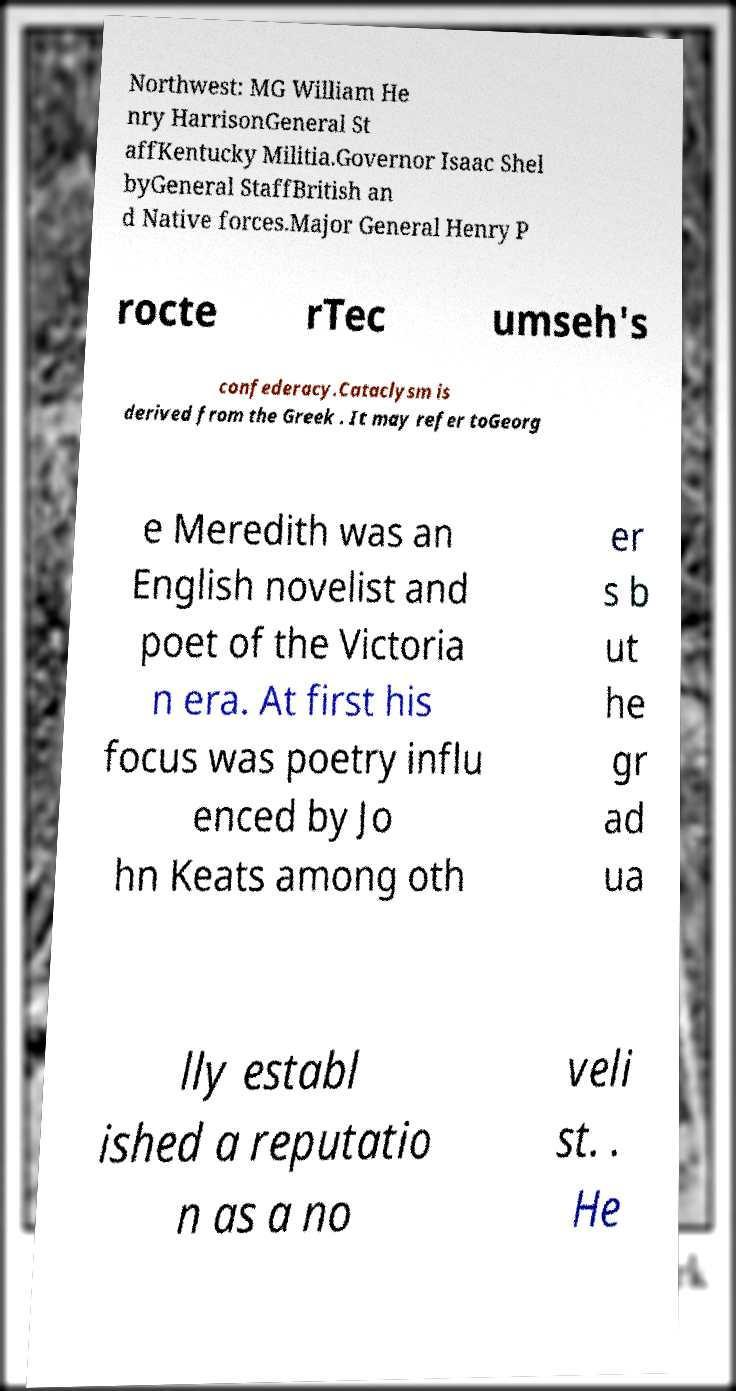Can you read and provide the text displayed in the image?This photo seems to have some interesting text. Can you extract and type it out for me? Northwest: MG William He nry HarrisonGeneral St affKentucky Militia.Governor Isaac Shel byGeneral StaffBritish an d Native forces.Major General Henry P rocte rTec umseh's confederacy.Cataclysm is derived from the Greek . It may refer toGeorg e Meredith was an English novelist and poet of the Victoria n era. At first his focus was poetry influ enced by Jo hn Keats among oth er s b ut he gr ad ua lly establ ished a reputatio n as a no veli st. . He 